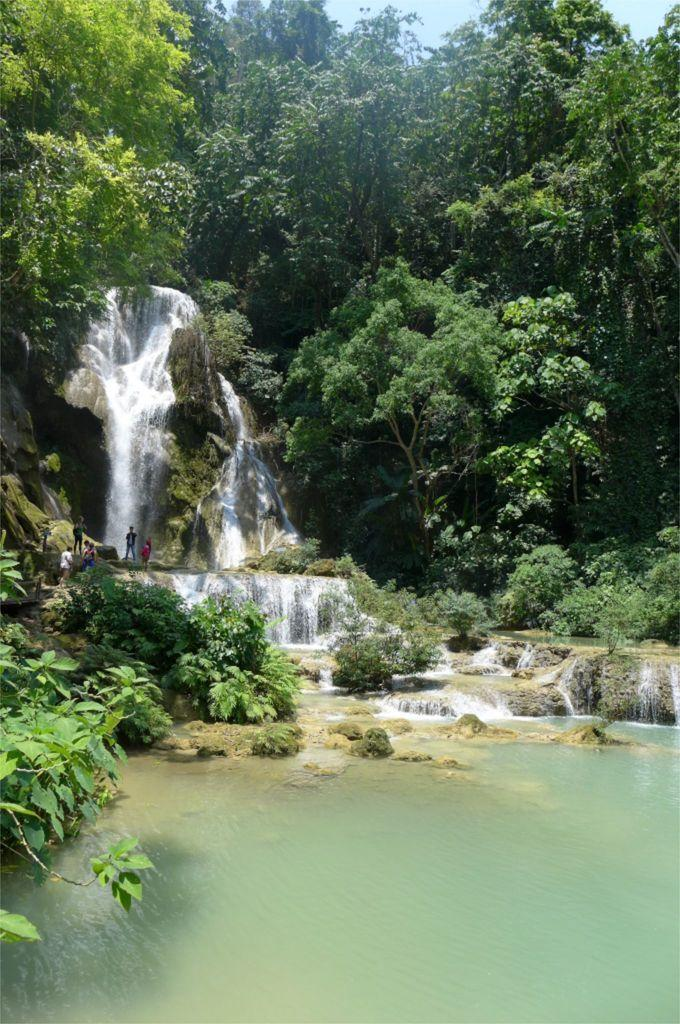What natural feature is the main subject of the image? There is a waterfall in the image. Are there any living beings present in the image? Yes, there are people in the image. What type of vegetation can be seen in the image? There are plants and trees in the image. What type of geological feature is present in the image? There are rocks in the image. How many brothers are standing near the waterfall in the image? There is no mention of brothers in the image, and therefore we cannot determine their presence or number. 